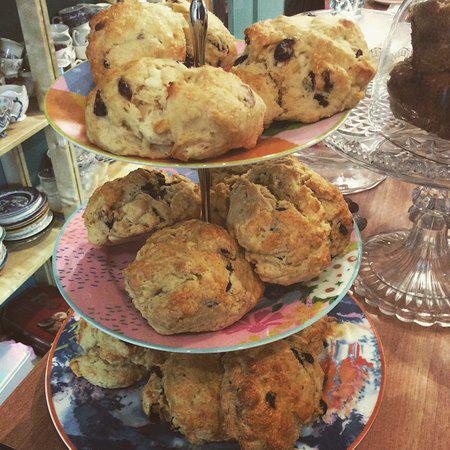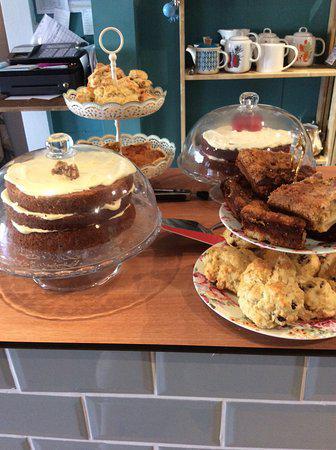The first image is the image on the left, the second image is the image on the right. For the images shown, is this caption "Each image features baked treats displayed on tiered plates, and porcelain teapots are in the background of at least one image." true? Answer yes or no. Yes. The first image is the image on the left, the second image is the image on the right. Assess this claim about the two images: "At least one saucer in the image on the left has a coffee cup on top of it.". Correct or not? Answer yes or no. No. 